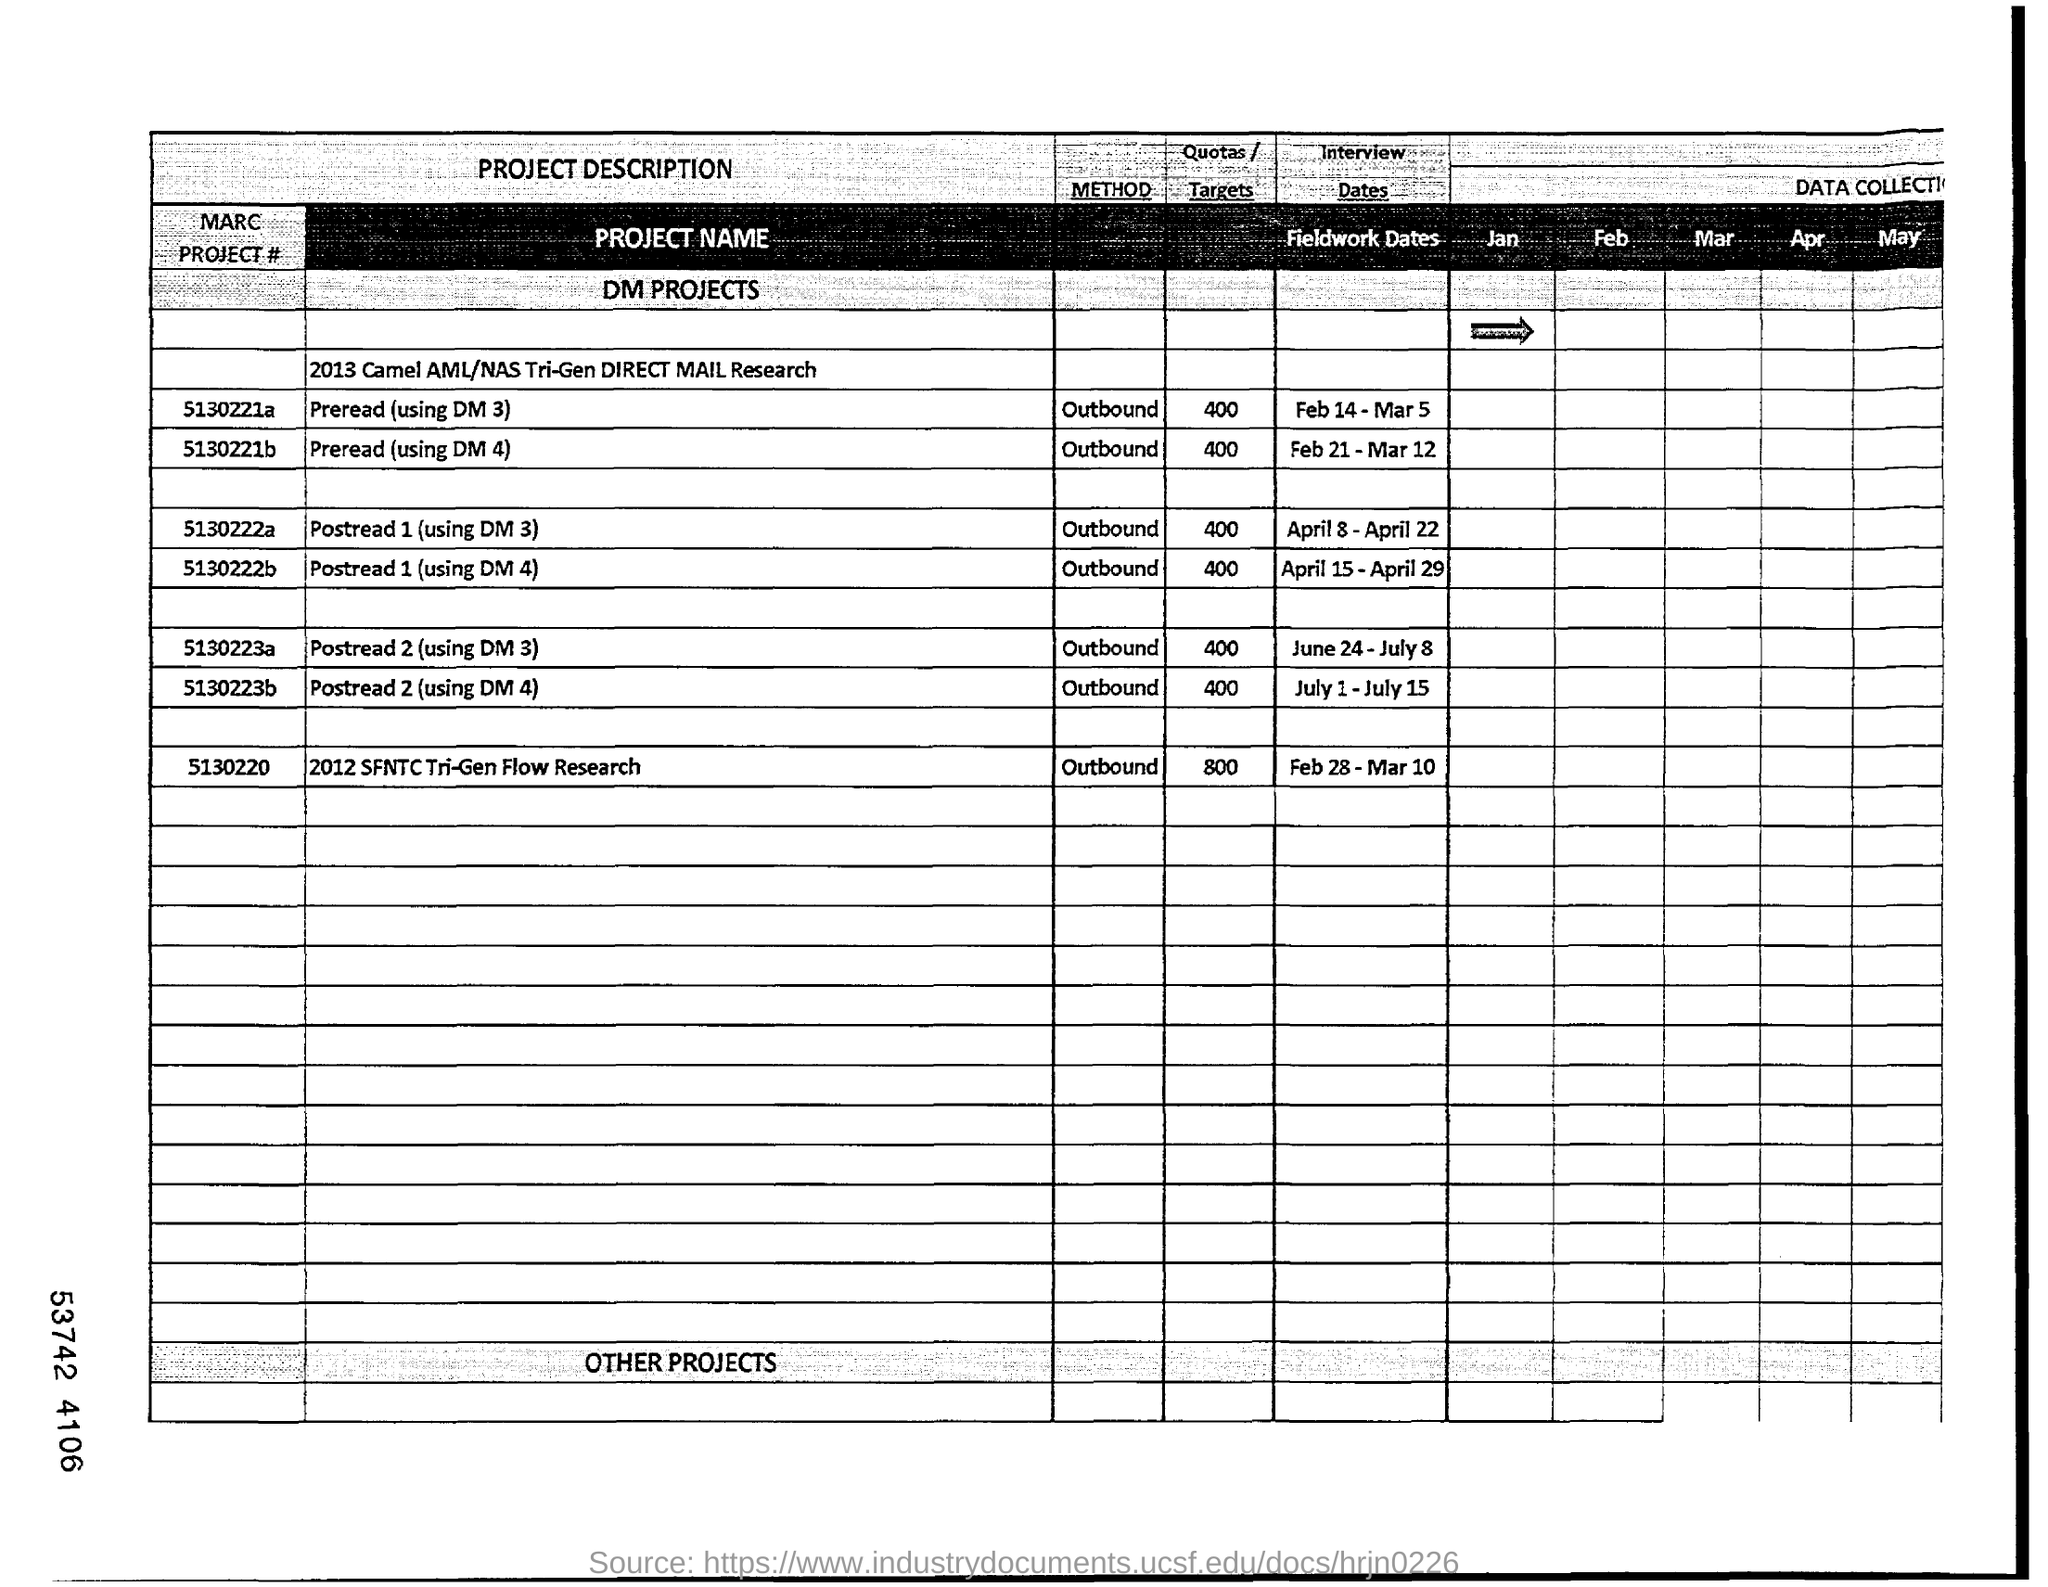What is the "METHOD"  of  MARC PROJECT # "5130221a"?
Your answer should be compact. Outbound. What is the "Quotas/Targets" of  MARC PROJECT #  "5130221a"?
Your answer should be compact. 400. What  is the date mentioned under "Interview Dates" for  MARC PROJECT # "5130221a"?
Your answer should be very brief. Feb 14 - Mar 5. What is the "Quotas/Targets" of MARC PROJECT #  "5130220"?
Give a very brief answer. 800. Mention the "PROJECT NAME " of MARC PROJECT # "5130221a" given in the table?
Your response must be concise. Preread (using DM 3). What is the "METHOD" of MARC PROJECT # "5130222a"?
Keep it short and to the point. Outbound. What is the "Quotas/Targets" of MARC PROJECT # "5130222a"?
Provide a succinct answer. 400. What is the date mentioned under "Interview Dates" for MARC PROJECT # "5130222a"?
Offer a very short reply. April 8 - April 22. What is the "PROJECT NAME" of  MARC PROJECT # "5130220"?
Offer a terse response. 2012 SFNTC Tri-Gen Flow Research. What is the date mentioned under "Interview Dates" for MARC PROJECT # "5130220"?
Your response must be concise. Feb 28 - Mar 10. 